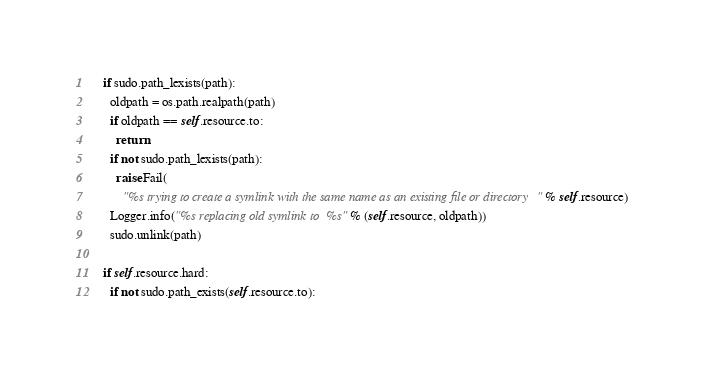<code> <loc_0><loc_0><loc_500><loc_500><_Python_>    if sudo.path_lexists(path):
      oldpath = os.path.realpath(path)
      if oldpath == self.resource.to:
        return
      if not sudo.path_lexists(path):
        raise Fail(
          "%s trying to create a symlink with the same name as an existing file or directory" % self.resource)
      Logger.info("%s replacing old symlink to %s" % (self.resource, oldpath))
      sudo.unlink(path)
      
    if self.resource.hard:
      if not sudo.path_exists(self.resource.to):</code> 